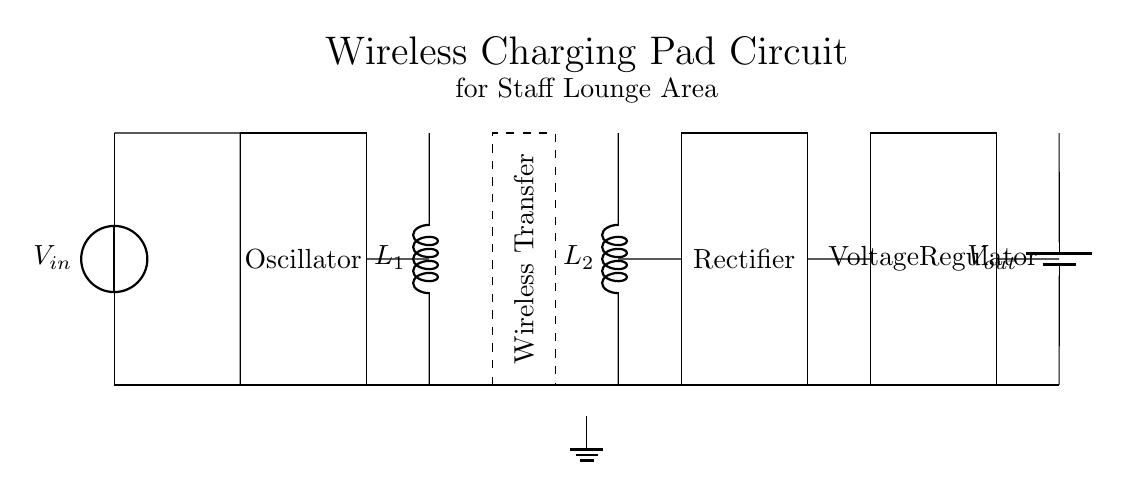What type of circuit is depicted? The circuit is a wireless charging pad circuit, which is characterized by inductively coupling energy to charge devices without physical connections.
Answer: wireless charging What is the purpose of the oscillator? The oscillator generates an alternating current that is necessary for creating a magnetic field in the transmitter coil, which assists in wireless energy transfer.
Answer: generates alternating current What do L1 and L2 represent in the diagram? L1 and L2 represent the transmitter and receiver inductors, respectively, which are essential components in inductive charging for transferring energy wirelessly.
Answer: inductors Which component rectifies the alternating current? The rectifier converts the alternating current from the receiver coil back into direct current for usable output.
Answer: rectifier How many main components are involved in the charging process? There are five main components in the charging process: the oscillator, transmitter coil, receiver coil, rectifier, and voltage regulator.
Answer: five What is the output voltage denoted as in the circuit? The output voltage is indicated as Vout, representing the voltage available after processing through the rectifier and regulator.
Answer: Vout What role does the voltage regulator serve in this circuit? The voltage regulator ensures that the output voltage remains stable and within a certain range, regardless of fluctuations in input or load conditions.
Answer: stabilizes output voltage 